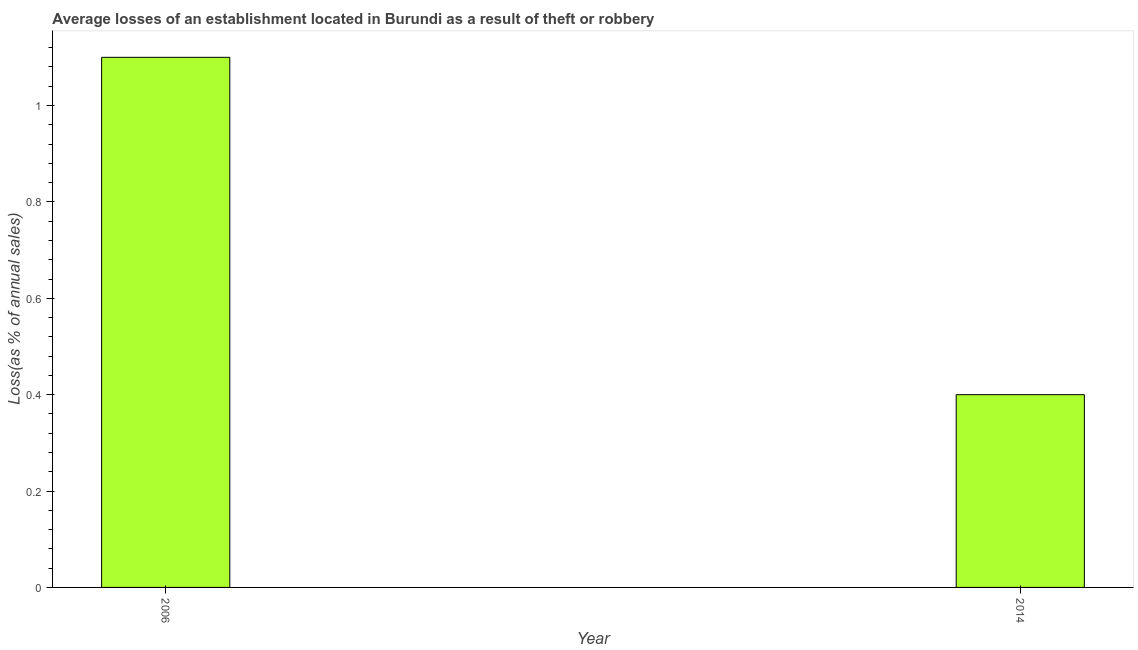Does the graph contain any zero values?
Provide a short and direct response. No. What is the title of the graph?
Offer a very short reply. Average losses of an establishment located in Burundi as a result of theft or robbery. What is the label or title of the X-axis?
Your response must be concise. Year. What is the label or title of the Y-axis?
Your answer should be very brief. Loss(as % of annual sales). Across all years, what is the maximum losses due to theft?
Make the answer very short. 1.1. Across all years, what is the minimum losses due to theft?
Offer a terse response. 0.4. What is the median losses due to theft?
Provide a short and direct response. 0.75. Do a majority of the years between 2014 and 2006 (inclusive) have losses due to theft greater than 0.6 %?
Provide a short and direct response. No. What is the ratio of the losses due to theft in 2006 to that in 2014?
Your response must be concise. 2.75. In how many years, is the losses due to theft greater than the average losses due to theft taken over all years?
Your response must be concise. 1. How many bars are there?
Your answer should be compact. 2. Are all the bars in the graph horizontal?
Make the answer very short. No. What is the difference between two consecutive major ticks on the Y-axis?
Offer a very short reply. 0.2. Are the values on the major ticks of Y-axis written in scientific E-notation?
Your answer should be very brief. No. What is the Loss(as % of annual sales) of 2014?
Offer a very short reply. 0.4. What is the difference between the Loss(as % of annual sales) in 2006 and 2014?
Offer a terse response. 0.7. What is the ratio of the Loss(as % of annual sales) in 2006 to that in 2014?
Provide a succinct answer. 2.75. 